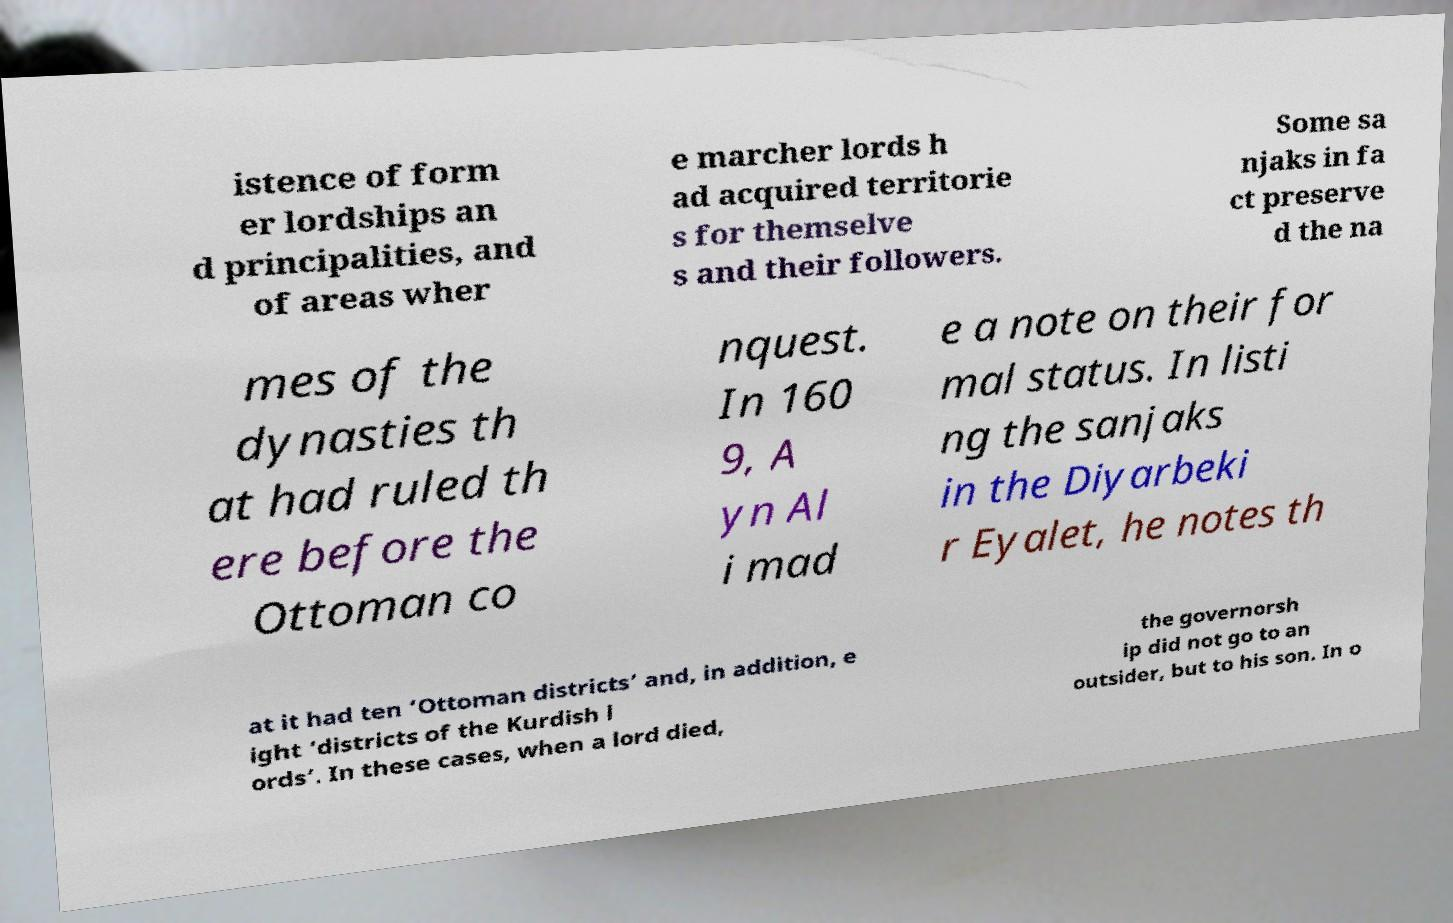Please read and relay the text visible in this image. What does it say? istence of form er lordships an d principalities, and of areas wher e marcher lords h ad acquired territorie s for themselve s and their followers. Some sa njaks in fa ct preserve d the na mes of the dynasties th at had ruled th ere before the Ottoman co nquest. In 160 9, A yn Al i mad e a note on their for mal status. In listi ng the sanjaks in the Diyarbeki r Eyalet, he notes th at it had ten ‘Ottoman districts’ and, in addition, e ight ‘districts of the Kurdish l ords’. In these cases, when a lord died, the governorsh ip did not go to an outsider, but to his son. In o 